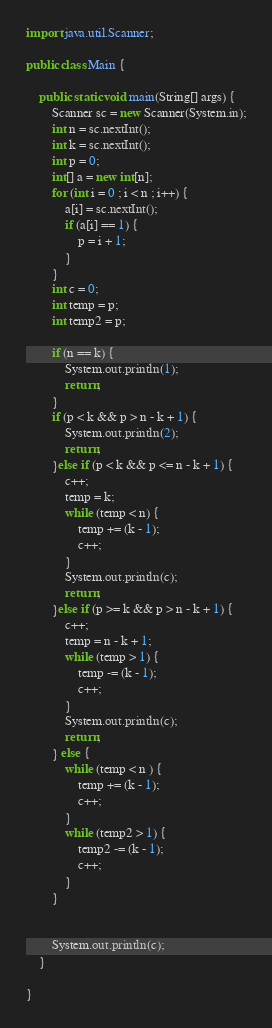<code> <loc_0><loc_0><loc_500><loc_500><_Java_>import java.util.Scanner;

public class Main {

    public static void main(String[] args) {
        Scanner sc = new Scanner(System.in);
        int n = sc.nextInt();
        int k = sc.nextInt();
        int p = 0;
        int[] a = new int[n];
        for (int i = 0 ; i < n ; i++) {
            a[i] = sc.nextInt();
            if (a[i] == 1) {
                p = i + 1;
            }
        }
        int c = 0;
        int temp = p;
        int temp2 = p;

        if (n == k) {
            System.out.println(1);
            return;
        }
        if (p < k && p > n - k + 1) {
            System.out.println(2);
            return;
        }else if (p < k && p <= n - k + 1) {
            c++;
            temp = k;
            while (temp < n) {
                temp += (k - 1);
                c++;
            }
            System.out.println(c);
            return;
        }else if (p >= k && p > n - k + 1) {
            c++;
            temp = n - k + 1;
            while (temp > 1) {
                temp -= (k - 1);
                c++;
            }
            System.out.println(c);
            return;
        } else {
            while (temp < n ) {
                temp += (k - 1);
                c++;
            }
            while (temp2 > 1) {
                temp2 -= (k - 1);
                c++;
            }
        }


        System.out.println(c);
    }

}</code> 